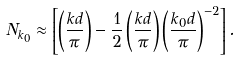Convert formula to latex. <formula><loc_0><loc_0><loc_500><loc_500>N _ { k _ { 0 } } \approx \left [ \left ( \frac { k d } { \pi } \right ) - \frac { 1 } { 2 } \left ( \frac { k d } { \pi } \right ) \left ( \frac { k _ { 0 } d } { \pi } \right ) ^ { - 2 } \right ] .</formula> 